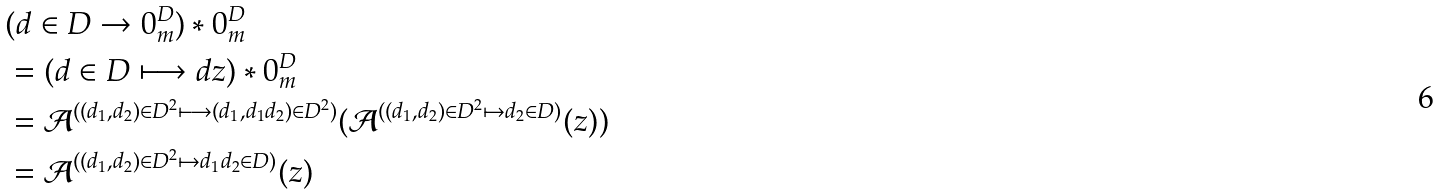<formula> <loc_0><loc_0><loc_500><loc_500>& ( d \in D \rightarrow 0 _ { m } ^ { D } ) \ast 0 _ { m } ^ { D } \\ & = ( d \in D \longmapsto d z ) \ast 0 _ { m } ^ { D } \\ & = \mathcal { A } ^ { ( ( d _ { 1 } , d _ { 2 } ) \in D ^ { 2 } \longmapsto ( d _ { 1 } , d _ { 1 } d _ { 2 } ) \in D ^ { 2 } ) } ( \mathcal { A } ^ { ( ( d _ { 1 } , d _ { 2 } ) \in D ^ { 2 } \mapsto d _ { 2 } \in D ) } ( z ) ) \\ & = \mathcal { A } ^ { ( ( d _ { 1 } , d _ { 2 } ) \in D ^ { 2 } \mapsto d _ { 1 } d _ { 2 } \in D ) } ( z )</formula> 